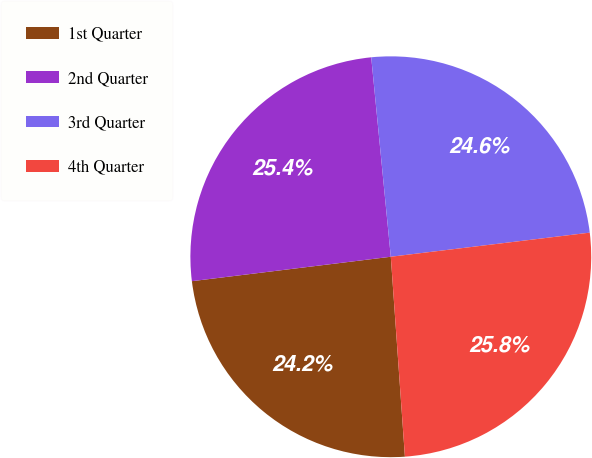<chart> <loc_0><loc_0><loc_500><loc_500><pie_chart><fcel>1st Quarter<fcel>2nd Quarter<fcel>3rd Quarter<fcel>4th Quarter<nl><fcel>24.18%<fcel>25.39%<fcel>24.64%<fcel>25.8%<nl></chart> 